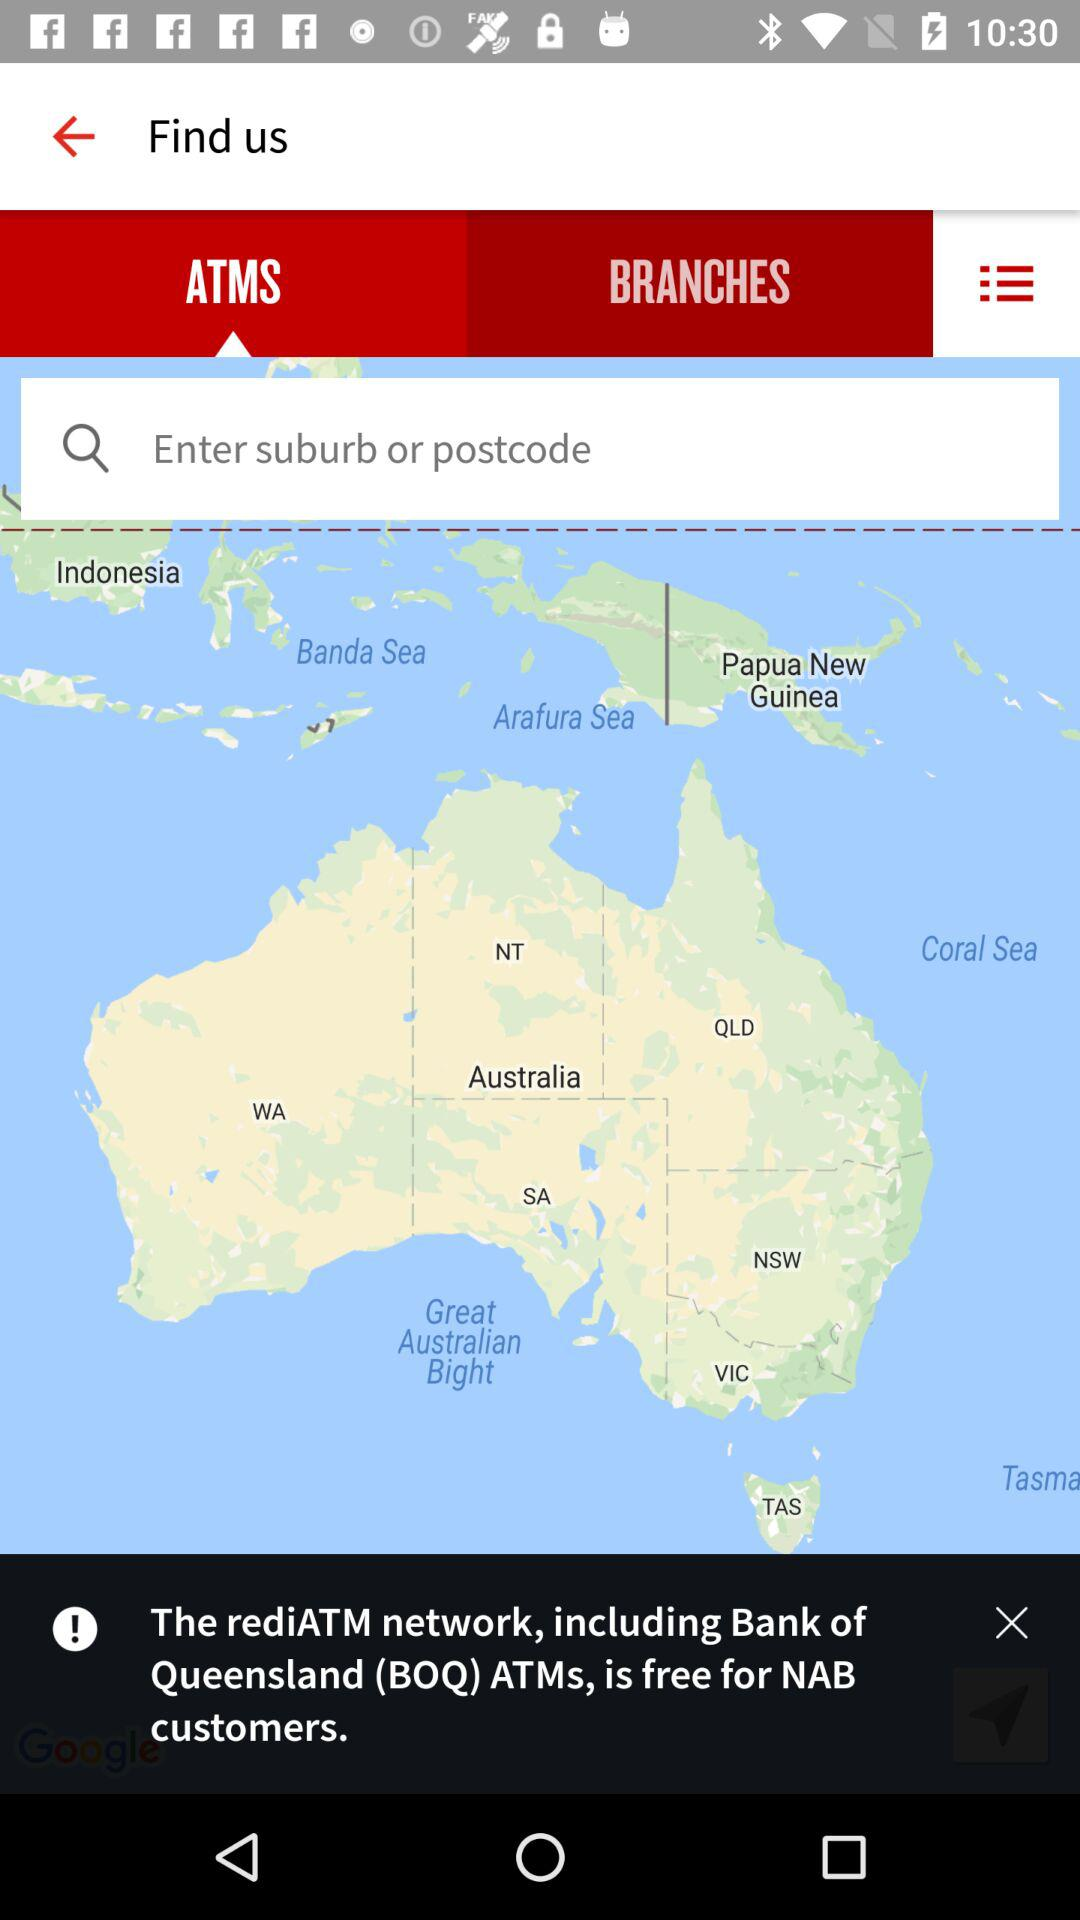Which tab is currently selected? The currently selected tab is "ATMS". 